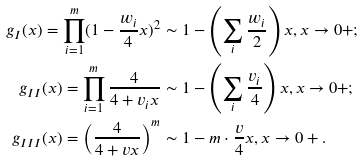<formula> <loc_0><loc_0><loc_500><loc_500>g _ { I } ( x ) = \prod _ { i = 1 } ^ { m } ( 1 - \frac { w _ { i } } { 4 } x ) ^ { 2 } & \sim 1 - \left ( \sum _ { i } \frac { w _ { i } } { 2 } \right ) x , x \to 0 + ; \\ g _ { I I } ( x ) = \prod _ { i = 1 } ^ { m } \frac { 4 } { 4 + v _ { i } x } & \sim 1 - \left ( \sum _ { i } \frac { v _ { i } } { 4 } \right ) x , x \to 0 + ; \\ g _ { I I I } ( x ) = \left ( \frac { 4 } { 4 + v x } \right ) ^ { m } & \sim 1 - m \cdot \frac { v } { 4 } x , x \to 0 + .</formula> 